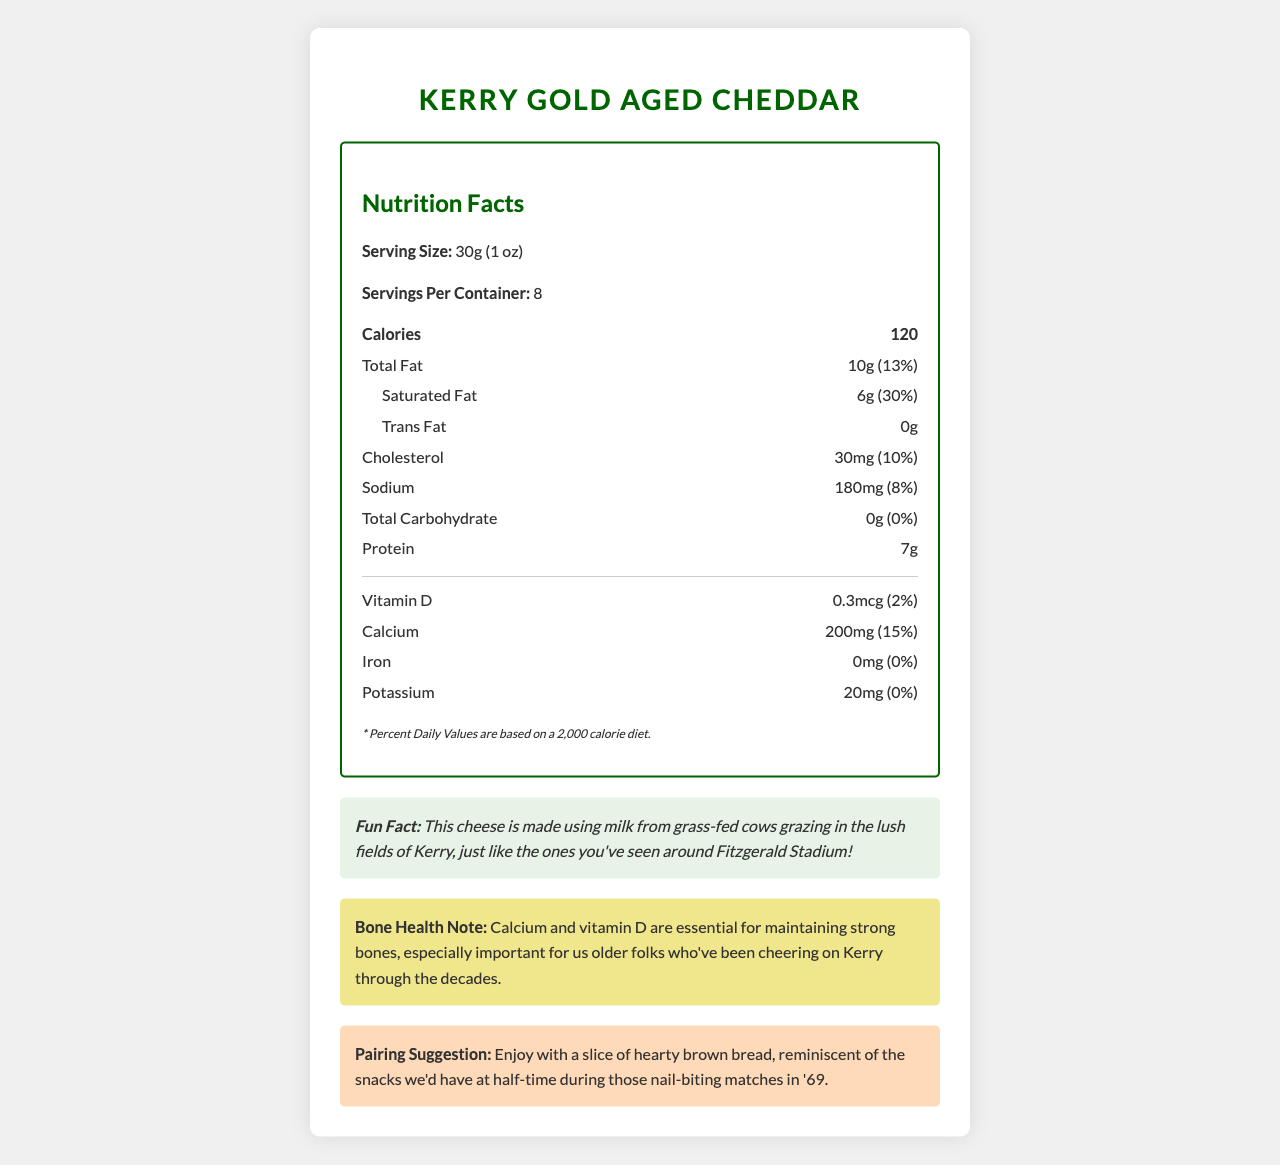what is the serving size? The serving size is clearly stated as 30g (1 oz) in the Nutrition Facts section.
Answer: 30g (1 oz) how many servings are there per container? There are 8 servings per container as indicated in the Nutrition Facts section.
Answer: 8 how many calories are in one serving? One serving contains 120 calories, as shown in the emphasized "Calories" section.
Answer: 120 how much saturated fat is in one serving? The Nutrition Facts section lists the saturated fat content as 6g per serving.
Answer: 6g what is the percentage of the daily value of calcium per serving? The document states that one serving provides 15% of the daily value for calcium.
Answer: 15% where is the cheese manufactured? The manufacturer information indicates that the cheese is made by Kerry Gold Dairy in Listowel, Co. Kerry.
Answer: Kerry Gold Dairy, Listowel, Co. Kerry what is the pairing suggestion for Kerry Gold Aged Cheddar? The Pairing Suggestion section suggests enjoying the cheese with a slice of hearty brown bread.
Answer: Enjoy with a slice of hearty brown bread what are the main ingredients in this cheese? The ingredients listed are pasteurized milk, salt, cheese cultures, and enzymes.
Answer: Pasteurized milk, salt, cheese cultures, enzymes what is the fun fact about this cheese? The Fun Fact section mentions that the cheese is made from milk of grass-fed cows in the fields of Kerry.
Answer: This cheese is made using milk from grass-fed cows grazing in the lush fields of Kerry, just like the ones you've seen around Fitzgerald Stadium! what is the bone health note mentioned? The Bone Health Note section says that calcium and vitamin D are crucial for maintaining strong bones, particularly for older individuals.
Answer: Calcium and vitamin D are essential for maintaining strong bones, especially important for us older folks who've been cheering on Kerry through the decades. how much vitamin D is in one serving? The amount of vitamin D per serving is specified as 0.3mcg in the Nutrition Facts section.
Answer: 0.3mcg which nutrient contributes the most to the daily value percentage per serving? Among the nutrients listed, saturated fat has the highest daily value percentage at 30%.
Answer: Saturated fat at 30% how should the cheese be stored? The storage instruction for the cheese indicates it should be kept refrigerated.
Answer: Keep refrigerated what is the daily value percentage for vitamin B12 in one serving? A. 17% B. 6% C. 12% The daily value percentage for vitamin B12 in one serving is 17% as noted in the Nutrition Facts section.
Answer: A what is not listed in the nutritional information for iron? A. 15% B. 0% C. 12% The daily value for iron is listed as 0%.
Answer: B is there any trans fat in the Kerry Gold Aged Cheddar? The Nutrition Facts section clearly states that the trans fat content is 0g per serving.
Answer: No does the product contain any dietary fiber? The document shows that the dietary fiber content is 0g per serving.
Answer: No describe the entire document or the main idea of it. The main purpose of the document is to inform consumers about the nutritional properties of the cheese, its health benefits, and suggested uses, adding a personal touch with fun facts and historical references.
Answer: The document provides detailed nutritional information and facts about Kerry Gold Aged Cheddar. It includes calorie count, serving size, and the amounts and daily values for various nutrients. Additionally, it has sections highlighting the fun fact, bone health note, and a pairing suggestion. The cheese is manufactured by Kerry Gold Dairy and should be kept refrigerated. how many grams of protein are in one serving? The document states that there are 7 grams of protein per serving.
Answer: 7g what is the cholesterol content in one serving? The cholesterol content per serving is listed as 30mg in the Nutrition Facts section.
Answer: 30mg where can I find the expiry date of this cheese? The document does not provide any information about the expiry date of the cheese.
Answer: Not enough information 